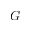<formula> <loc_0><loc_0><loc_500><loc_500>G</formula> 